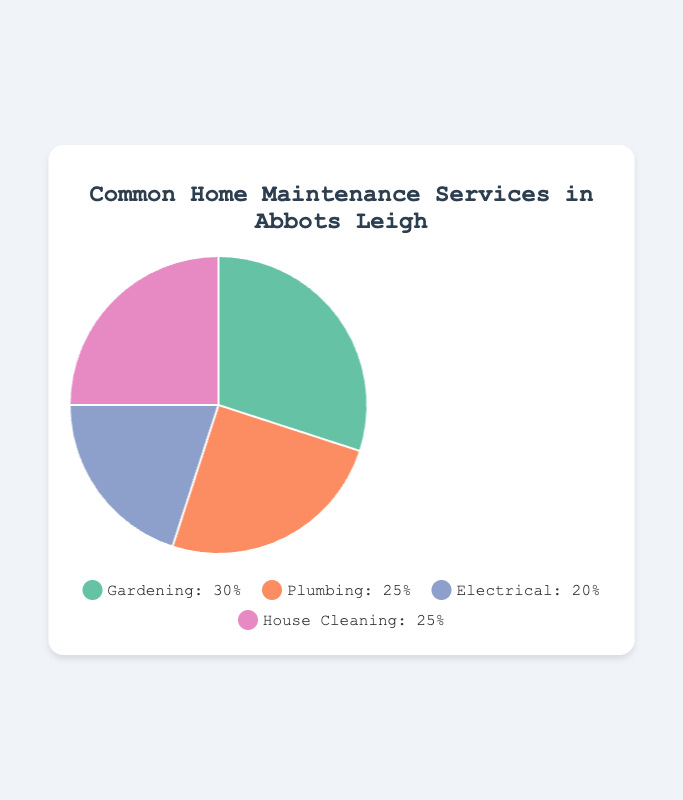Which home maintenance service is used the most? By looking at the chart, the section with the largest percentage indicates the most used service. Gardening has the largest section at 30%.
Answer: Gardening Which home maintenance services have equal usage percentages? By examining the chart, we see that Plumbing and House Cleaning both have a slice of 25%.
Answer: Plumbing and House Cleaning What is the combined percentage usage of Plumbing and Electrical services? Add the percentages for Plumbing (25%) and Electrical (20%). The sum is 25% + 20% = 45%.
Answer: 45% How much more popular is Gardening compared to Electrical services? Subtract the percentage of Electrical (20%) from the percentage of Gardening (30%). The difference is 30% - 20% = 10%.
Answer: 10% Which service is represented by the yellow section? The color representations and legend in the chart show that Plumbing is associated with yellow.
Answer: Plumbing What percentage of households use either Plumbing or House Cleaning services? Add the percentages for Plumbing (25%) and House Cleaning (25%). The sum is 25% + 25% = 50%.
Answer: 50% Rank the services from most used to least used. By examining the percentages: Gardening (30%), Plumbing (25%) and House Cleaning (25%), Electrical (20%).
Answer: Gardening, Plumbing and House Cleaning, Electrical Is Electrical service usage less than 25%? The chart shows Electrical usage at 20%, which is less than 25%.
Answer: Yes Which service has a slightly higher usage percentage than Electrical? Compare the percentages: Plumbing is at 25%, which is higher than Electrical's 20%.
Answer: Plumbing What is the average percentage use across all services? Sum the percentages of all services and divide by the number of services (30% + 25% + 20% + 25%) / 4 = 25%.
Answer: 25% 